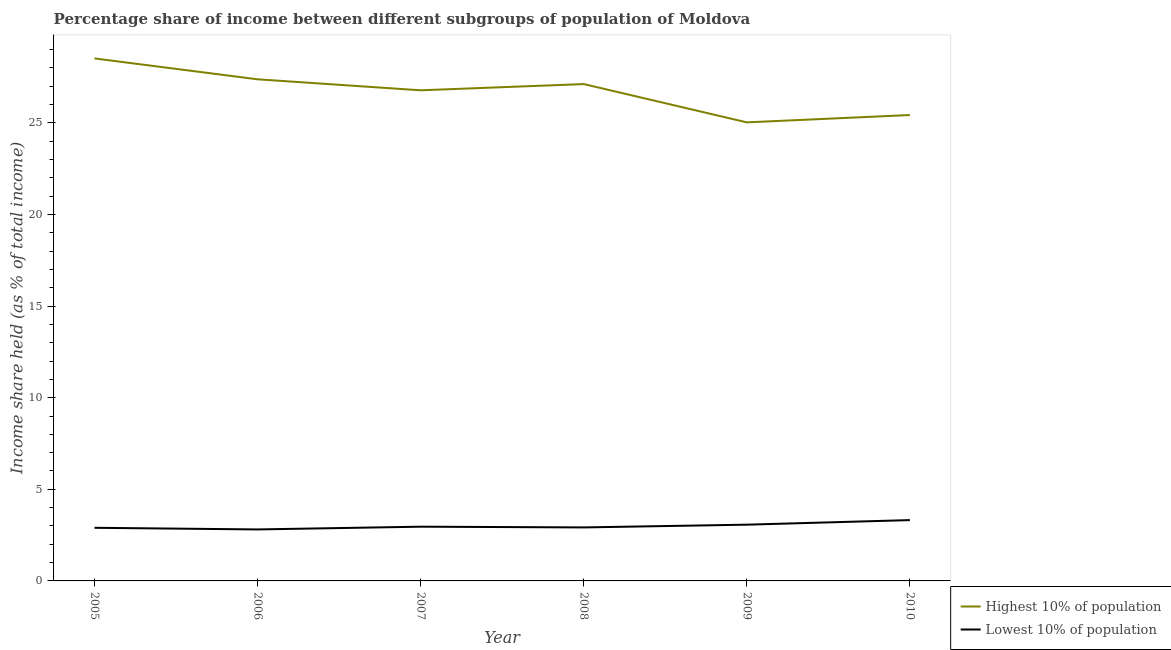Does the line corresponding to income share held by highest 10% of the population intersect with the line corresponding to income share held by lowest 10% of the population?
Provide a succinct answer. No. What is the income share held by lowest 10% of the population in 2010?
Offer a terse response. 3.32. Across all years, what is the maximum income share held by highest 10% of the population?
Keep it short and to the point. 28.52. Across all years, what is the minimum income share held by lowest 10% of the population?
Offer a very short reply. 2.81. In which year was the income share held by highest 10% of the population minimum?
Give a very brief answer. 2009. What is the total income share held by highest 10% of the population in the graph?
Provide a succinct answer. 160.26. What is the difference between the income share held by lowest 10% of the population in 2006 and that in 2007?
Provide a short and direct response. -0.15. What is the difference between the income share held by lowest 10% of the population in 2006 and the income share held by highest 10% of the population in 2010?
Give a very brief answer. -22.62. What is the average income share held by lowest 10% of the population per year?
Offer a very short reply. 3. In the year 2010, what is the difference between the income share held by lowest 10% of the population and income share held by highest 10% of the population?
Your answer should be very brief. -22.11. What is the ratio of the income share held by highest 10% of the population in 2009 to that in 2010?
Your response must be concise. 0.98. Is the income share held by highest 10% of the population in 2005 less than that in 2009?
Your answer should be compact. No. Is the difference between the income share held by lowest 10% of the population in 2006 and 2007 greater than the difference between the income share held by highest 10% of the population in 2006 and 2007?
Your answer should be very brief. No. What is the difference between the highest and the second highest income share held by highest 10% of the population?
Keep it short and to the point. 1.14. What is the difference between the highest and the lowest income share held by lowest 10% of the population?
Make the answer very short. 0.51. Does the income share held by highest 10% of the population monotonically increase over the years?
Your answer should be very brief. No. Is the income share held by highest 10% of the population strictly greater than the income share held by lowest 10% of the population over the years?
Make the answer very short. Yes. Is the income share held by lowest 10% of the population strictly less than the income share held by highest 10% of the population over the years?
Your response must be concise. Yes. What is the difference between two consecutive major ticks on the Y-axis?
Offer a very short reply. 5. Are the values on the major ticks of Y-axis written in scientific E-notation?
Your answer should be very brief. No. Does the graph contain any zero values?
Offer a very short reply. No. Does the graph contain grids?
Keep it short and to the point. No. Where does the legend appear in the graph?
Give a very brief answer. Bottom right. How many legend labels are there?
Make the answer very short. 2. What is the title of the graph?
Provide a short and direct response. Percentage share of income between different subgroups of population of Moldova. Does "Largest city" appear as one of the legend labels in the graph?
Offer a very short reply. No. What is the label or title of the X-axis?
Give a very brief answer. Year. What is the label or title of the Y-axis?
Provide a succinct answer. Income share held (as % of total income). What is the Income share held (as % of total income) in Highest 10% of population in 2005?
Your answer should be compact. 28.52. What is the Income share held (as % of total income) in Lowest 10% of population in 2005?
Offer a terse response. 2.9. What is the Income share held (as % of total income) in Highest 10% of population in 2006?
Make the answer very short. 27.38. What is the Income share held (as % of total income) of Lowest 10% of population in 2006?
Ensure brevity in your answer.  2.81. What is the Income share held (as % of total income) of Highest 10% of population in 2007?
Ensure brevity in your answer.  26.78. What is the Income share held (as % of total income) in Lowest 10% of population in 2007?
Your answer should be compact. 2.96. What is the Income share held (as % of total income) of Highest 10% of population in 2008?
Offer a terse response. 27.12. What is the Income share held (as % of total income) of Lowest 10% of population in 2008?
Make the answer very short. 2.92. What is the Income share held (as % of total income) in Highest 10% of population in 2009?
Provide a succinct answer. 25.03. What is the Income share held (as % of total income) of Lowest 10% of population in 2009?
Keep it short and to the point. 3.07. What is the Income share held (as % of total income) in Highest 10% of population in 2010?
Your answer should be very brief. 25.43. What is the Income share held (as % of total income) of Lowest 10% of population in 2010?
Make the answer very short. 3.32. Across all years, what is the maximum Income share held (as % of total income) of Highest 10% of population?
Keep it short and to the point. 28.52. Across all years, what is the maximum Income share held (as % of total income) of Lowest 10% of population?
Offer a terse response. 3.32. Across all years, what is the minimum Income share held (as % of total income) of Highest 10% of population?
Provide a short and direct response. 25.03. Across all years, what is the minimum Income share held (as % of total income) of Lowest 10% of population?
Your response must be concise. 2.81. What is the total Income share held (as % of total income) in Highest 10% of population in the graph?
Your response must be concise. 160.26. What is the total Income share held (as % of total income) in Lowest 10% of population in the graph?
Offer a terse response. 17.98. What is the difference between the Income share held (as % of total income) in Highest 10% of population in 2005 and that in 2006?
Make the answer very short. 1.14. What is the difference between the Income share held (as % of total income) of Lowest 10% of population in 2005 and that in 2006?
Keep it short and to the point. 0.09. What is the difference between the Income share held (as % of total income) in Highest 10% of population in 2005 and that in 2007?
Offer a very short reply. 1.74. What is the difference between the Income share held (as % of total income) of Lowest 10% of population in 2005 and that in 2007?
Provide a short and direct response. -0.06. What is the difference between the Income share held (as % of total income) in Highest 10% of population in 2005 and that in 2008?
Your answer should be very brief. 1.4. What is the difference between the Income share held (as % of total income) in Lowest 10% of population in 2005 and that in 2008?
Ensure brevity in your answer.  -0.02. What is the difference between the Income share held (as % of total income) in Highest 10% of population in 2005 and that in 2009?
Ensure brevity in your answer.  3.49. What is the difference between the Income share held (as % of total income) of Lowest 10% of population in 2005 and that in 2009?
Ensure brevity in your answer.  -0.17. What is the difference between the Income share held (as % of total income) in Highest 10% of population in 2005 and that in 2010?
Your answer should be compact. 3.09. What is the difference between the Income share held (as % of total income) of Lowest 10% of population in 2005 and that in 2010?
Offer a terse response. -0.42. What is the difference between the Income share held (as % of total income) in Highest 10% of population in 2006 and that in 2008?
Give a very brief answer. 0.26. What is the difference between the Income share held (as % of total income) in Lowest 10% of population in 2006 and that in 2008?
Offer a very short reply. -0.11. What is the difference between the Income share held (as % of total income) in Highest 10% of population in 2006 and that in 2009?
Make the answer very short. 2.35. What is the difference between the Income share held (as % of total income) in Lowest 10% of population in 2006 and that in 2009?
Your response must be concise. -0.26. What is the difference between the Income share held (as % of total income) in Highest 10% of population in 2006 and that in 2010?
Offer a terse response. 1.95. What is the difference between the Income share held (as % of total income) in Lowest 10% of population in 2006 and that in 2010?
Ensure brevity in your answer.  -0.51. What is the difference between the Income share held (as % of total income) in Highest 10% of population in 2007 and that in 2008?
Your answer should be very brief. -0.34. What is the difference between the Income share held (as % of total income) of Lowest 10% of population in 2007 and that in 2008?
Keep it short and to the point. 0.04. What is the difference between the Income share held (as % of total income) of Highest 10% of population in 2007 and that in 2009?
Your answer should be compact. 1.75. What is the difference between the Income share held (as % of total income) in Lowest 10% of population in 2007 and that in 2009?
Provide a succinct answer. -0.11. What is the difference between the Income share held (as % of total income) in Highest 10% of population in 2007 and that in 2010?
Offer a terse response. 1.35. What is the difference between the Income share held (as % of total income) in Lowest 10% of population in 2007 and that in 2010?
Make the answer very short. -0.36. What is the difference between the Income share held (as % of total income) in Highest 10% of population in 2008 and that in 2009?
Make the answer very short. 2.09. What is the difference between the Income share held (as % of total income) in Lowest 10% of population in 2008 and that in 2009?
Your answer should be very brief. -0.15. What is the difference between the Income share held (as % of total income) of Highest 10% of population in 2008 and that in 2010?
Provide a succinct answer. 1.69. What is the difference between the Income share held (as % of total income) of Lowest 10% of population in 2008 and that in 2010?
Offer a very short reply. -0.4. What is the difference between the Income share held (as % of total income) in Highest 10% of population in 2005 and the Income share held (as % of total income) in Lowest 10% of population in 2006?
Your answer should be very brief. 25.71. What is the difference between the Income share held (as % of total income) of Highest 10% of population in 2005 and the Income share held (as % of total income) of Lowest 10% of population in 2007?
Your response must be concise. 25.56. What is the difference between the Income share held (as % of total income) in Highest 10% of population in 2005 and the Income share held (as % of total income) in Lowest 10% of population in 2008?
Ensure brevity in your answer.  25.6. What is the difference between the Income share held (as % of total income) of Highest 10% of population in 2005 and the Income share held (as % of total income) of Lowest 10% of population in 2009?
Your response must be concise. 25.45. What is the difference between the Income share held (as % of total income) in Highest 10% of population in 2005 and the Income share held (as % of total income) in Lowest 10% of population in 2010?
Give a very brief answer. 25.2. What is the difference between the Income share held (as % of total income) in Highest 10% of population in 2006 and the Income share held (as % of total income) in Lowest 10% of population in 2007?
Give a very brief answer. 24.42. What is the difference between the Income share held (as % of total income) in Highest 10% of population in 2006 and the Income share held (as % of total income) in Lowest 10% of population in 2008?
Give a very brief answer. 24.46. What is the difference between the Income share held (as % of total income) in Highest 10% of population in 2006 and the Income share held (as % of total income) in Lowest 10% of population in 2009?
Keep it short and to the point. 24.31. What is the difference between the Income share held (as % of total income) of Highest 10% of population in 2006 and the Income share held (as % of total income) of Lowest 10% of population in 2010?
Provide a succinct answer. 24.06. What is the difference between the Income share held (as % of total income) of Highest 10% of population in 2007 and the Income share held (as % of total income) of Lowest 10% of population in 2008?
Give a very brief answer. 23.86. What is the difference between the Income share held (as % of total income) of Highest 10% of population in 2007 and the Income share held (as % of total income) of Lowest 10% of population in 2009?
Offer a very short reply. 23.71. What is the difference between the Income share held (as % of total income) in Highest 10% of population in 2007 and the Income share held (as % of total income) in Lowest 10% of population in 2010?
Give a very brief answer. 23.46. What is the difference between the Income share held (as % of total income) of Highest 10% of population in 2008 and the Income share held (as % of total income) of Lowest 10% of population in 2009?
Give a very brief answer. 24.05. What is the difference between the Income share held (as % of total income) of Highest 10% of population in 2008 and the Income share held (as % of total income) of Lowest 10% of population in 2010?
Your response must be concise. 23.8. What is the difference between the Income share held (as % of total income) in Highest 10% of population in 2009 and the Income share held (as % of total income) in Lowest 10% of population in 2010?
Your answer should be compact. 21.71. What is the average Income share held (as % of total income) in Highest 10% of population per year?
Offer a terse response. 26.71. What is the average Income share held (as % of total income) in Lowest 10% of population per year?
Give a very brief answer. 3. In the year 2005, what is the difference between the Income share held (as % of total income) of Highest 10% of population and Income share held (as % of total income) of Lowest 10% of population?
Ensure brevity in your answer.  25.62. In the year 2006, what is the difference between the Income share held (as % of total income) of Highest 10% of population and Income share held (as % of total income) of Lowest 10% of population?
Provide a short and direct response. 24.57. In the year 2007, what is the difference between the Income share held (as % of total income) of Highest 10% of population and Income share held (as % of total income) of Lowest 10% of population?
Provide a succinct answer. 23.82. In the year 2008, what is the difference between the Income share held (as % of total income) in Highest 10% of population and Income share held (as % of total income) in Lowest 10% of population?
Make the answer very short. 24.2. In the year 2009, what is the difference between the Income share held (as % of total income) in Highest 10% of population and Income share held (as % of total income) in Lowest 10% of population?
Your response must be concise. 21.96. In the year 2010, what is the difference between the Income share held (as % of total income) in Highest 10% of population and Income share held (as % of total income) in Lowest 10% of population?
Your response must be concise. 22.11. What is the ratio of the Income share held (as % of total income) of Highest 10% of population in 2005 to that in 2006?
Your answer should be compact. 1.04. What is the ratio of the Income share held (as % of total income) of Lowest 10% of population in 2005 to that in 2006?
Ensure brevity in your answer.  1.03. What is the ratio of the Income share held (as % of total income) of Highest 10% of population in 2005 to that in 2007?
Provide a short and direct response. 1.06. What is the ratio of the Income share held (as % of total income) of Lowest 10% of population in 2005 to that in 2007?
Make the answer very short. 0.98. What is the ratio of the Income share held (as % of total income) in Highest 10% of population in 2005 to that in 2008?
Give a very brief answer. 1.05. What is the ratio of the Income share held (as % of total income) of Lowest 10% of population in 2005 to that in 2008?
Provide a short and direct response. 0.99. What is the ratio of the Income share held (as % of total income) of Highest 10% of population in 2005 to that in 2009?
Give a very brief answer. 1.14. What is the ratio of the Income share held (as % of total income) of Lowest 10% of population in 2005 to that in 2009?
Provide a short and direct response. 0.94. What is the ratio of the Income share held (as % of total income) of Highest 10% of population in 2005 to that in 2010?
Provide a succinct answer. 1.12. What is the ratio of the Income share held (as % of total income) of Lowest 10% of population in 2005 to that in 2010?
Keep it short and to the point. 0.87. What is the ratio of the Income share held (as % of total income) in Highest 10% of population in 2006 to that in 2007?
Your answer should be compact. 1.02. What is the ratio of the Income share held (as % of total income) in Lowest 10% of population in 2006 to that in 2007?
Give a very brief answer. 0.95. What is the ratio of the Income share held (as % of total income) in Highest 10% of population in 2006 to that in 2008?
Offer a terse response. 1.01. What is the ratio of the Income share held (as % of total income) in Lowest 10% of population in 2006 to that in 2008?
Make the answer very short. 0.96. What is the ratio of the Income share held (as % of total income) in Highest 10% of population in 2006 to that in 2009?
Offer a very short reply. 1.09. What is the ratio of the Income share held (as % of total income) of Lowest 10% of population in 2006 to that in 2009?
Provide a succinct answer. 0.92. What is the ratio of the Income share held (as % of total income) of Highest 10% of population in 2006 to that in 2010?
Your answer should be very brief. 1.08. What is the ratio of the Income share held (as % of total income) in Lowest 10% of population in 2006 to that in 2010?
Give a very brief answer. 0.85. What is the ratio of the Income share held (as % of total income) in Highest 10% of population in 2007 to that in 2008?
Your response must be concise. 0.99. What is the ratio of the Income share held (as % of total income) of Lowest 10% of population in 2007 to that in 2008?
Your response must be concise. 1.01. What is the ratio of the Income share held (as % of total income) of Highest 10% of population in 2007 to that in 2009?
Make the answer very short. 1.07. What is the ratio of the Income share held (as % of total income) in Lowest 10% of population in 2007 to that in 2009?
Offer a terse response. 0.96. What is the ratio of the Income share held (as % of total income) of Highest 10% of population in 2007 to that in 2010?
Your response must be concise. 1.05. What is the ratio of the Income share held (as % of total income) of Lowest 10% of population in 2007 to that in 2010?
Keep it short and to the point. 0.89. What is the ratio of the Income share held (as % of total income) in Highest 10% of population in 2008 to that in 2009?
Your answer should be very brief. 1.08. What is the ratio of the Income share held (as % of total income) of Lowest 10% of population in 2008 to that in 2009?
Offer a terse response. 0.95. What is the ratio of the Income share held (as % of total income) of Highest 10% of population in 2008 to that in 2010?
Your answer should be compact. 1.07. What is the ratio of the Income share held (as % of total income) in Lowest 10% of population in 2008 to that in 2010?
Your answer should be compact. 0.88. What is the ratio of the Income share held (as % of total income) of Highest 10% of population in 2009 to that in 2010?
Your response must be concise. 0.98. What is the ratio of the Income share held (as % of total income) in Lowest 10% of population in 2009 to that in 2010?
Make the answer very short. 0.92. What is the difference between the highest and the second highest Income share held (as % of total income) in Highest 10% of population?
Make the answer very short. 1.14. What is the difference between the highest and the second highest Income share held (as % of total income) in Lowest 10% of population?
Make the answer very short. 0.25. What is the difference between the highest and the lowest Income share held (as % of total income) of Highest 10% of population?
Give a very brief answer. 3.49. What is the difference between the highest and the lowest Income share held (as % of total income) in Lowest 10% of population?
Your answer should be very brief. 0.51. 